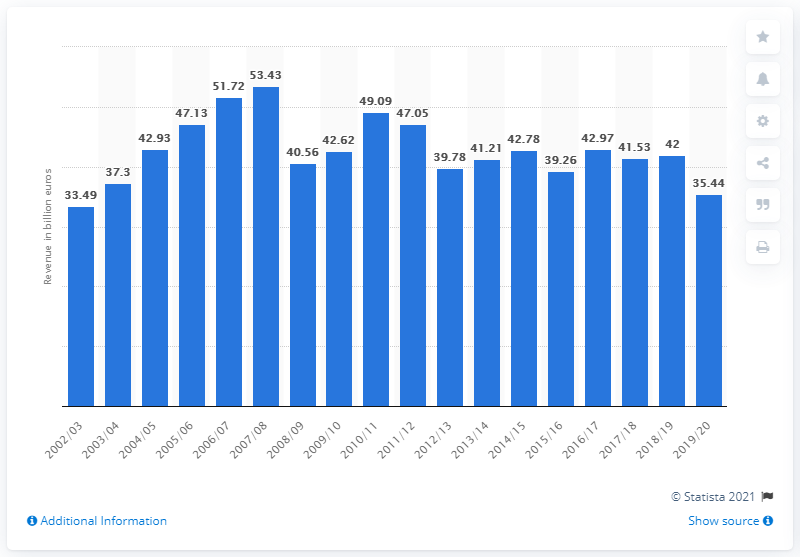Point out several critical features in this image. ThyssenKrupp's net sales for the fiscal year ended September 30, 2020, were 35.44. 